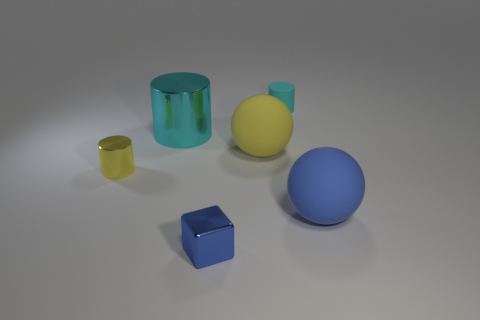Does the small matte cylinder have the same color as the shiny cube?
Ensure brevity in your answer.  No. There is a shiny object that is the same size as the yellow ball; what color is it?
Your response must be concise. Cyan. How many cyan objects are either small matte cylinders or large metallic cylinders?
Your response must be concise. 2. Are there more blue things than small gray shiny things?
Ensure brevity in your answer.  Yes. There is a rubber sphere that is right of the tiny rubber cylinder; does it have the same size as the cyan cylinder on the right side of the small blue metallic thing?
Offer a very short reply. No. What color is the matte sphere that is behind the big rubber object that is in front of the metal object left of the large metallic cylinder?
Offer a very short reply. Yellow. Are there any other tiny blue things of the same shape as the blue shiny object?
Provide a succinct answer. No. Is the number of tiny cubes to the right of the large blue thing greater than the number of blue shiny cubes?
Offer a terse response. No. What number of rubber things are red cylinders or yellow cylinders?
Your answer should be very brief. 0. What size is the thing that is both behind the yellow matte ball and right of the large cyan cylinder?
Provide a succinct answer. Small. 